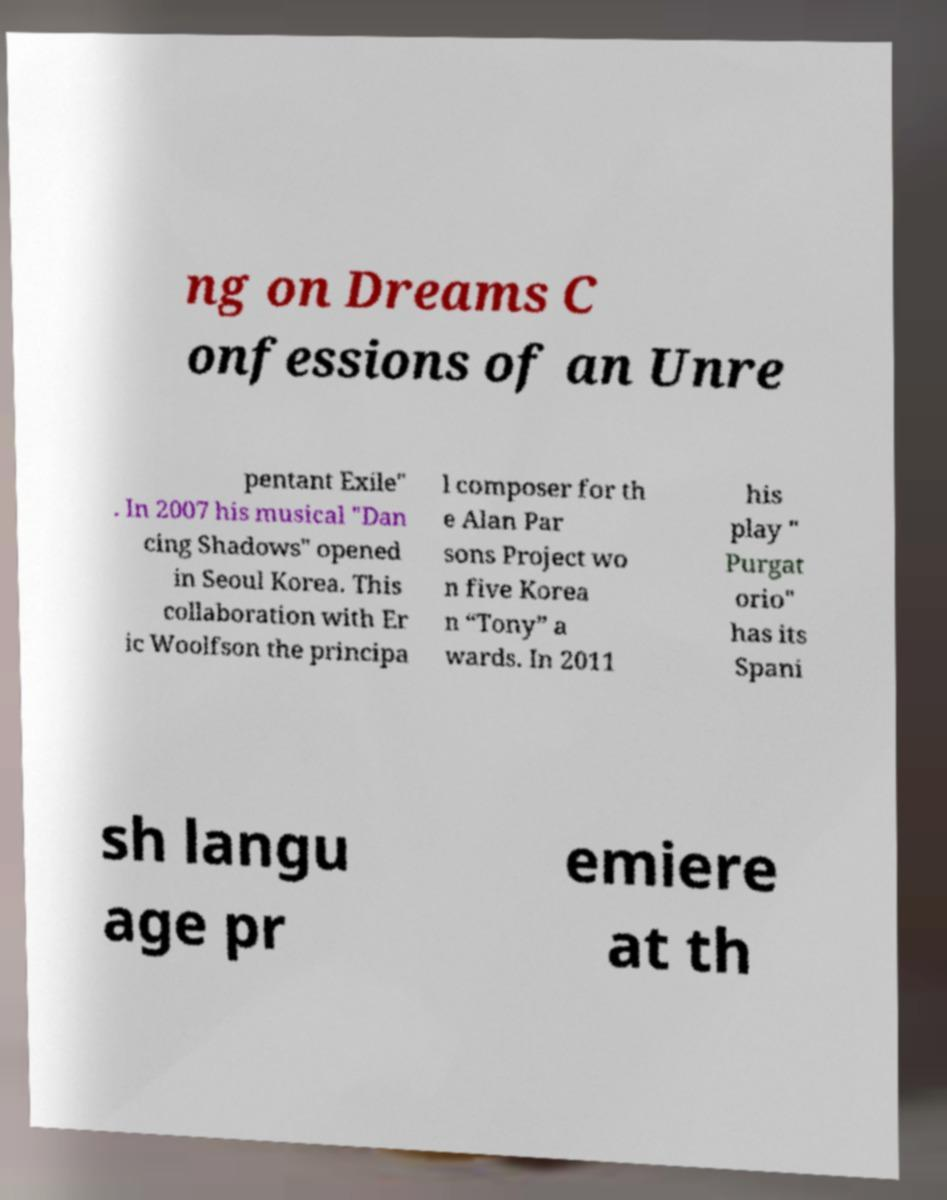For documentation purposes, I need the text within this image transcribed. Could you provide that? ng on Dreams C onfessions of an Unre pentant Exile" . In 2007 his musical "Dan cing Shadows" opened in Seoul Korea. This collaboration with Er ic Woolfson the principa l composer for th e Alan Par sons Project wo n five Korea n “Tony” a wards. In 2011 his play " Purgat orio" has its Spani sh langu age pr emiere at th 